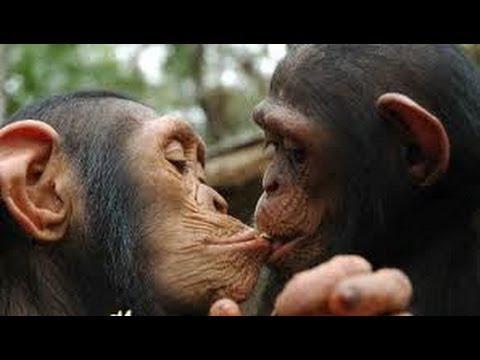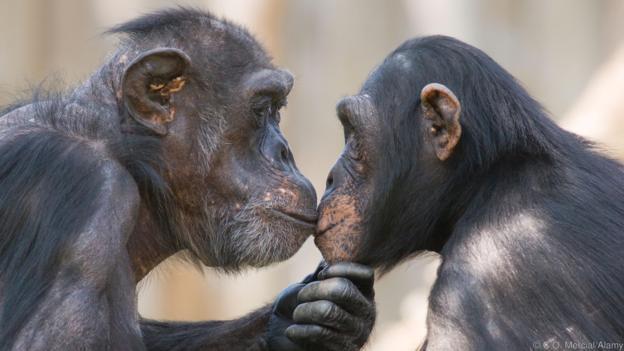The first image is the image on the left, the second image is the image on the right. Considering the images on both sides, is "Both images show a pair of chimps with their mouths very close together." valid? Answer yes or no. Yes. The first image is the image on the left, the second image is the image on the right. Examine the images to the left and right. Is the description "In one of the pictures, two primates kissing each other on the lips, and in the other, a baby primate is next to an adult." accurate? Answer yes or no. No. 